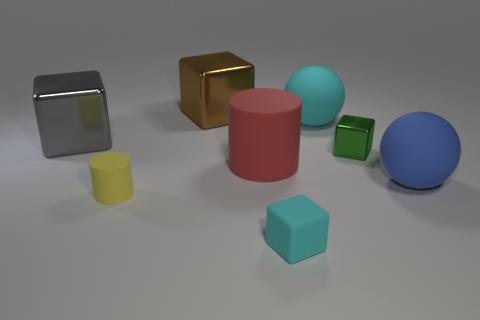There is a cyan object in front of the blue rubber ball; is its shape the same as the gray object?
Make the answer very short. Yes. What number of matte objects are on the left side of the large blue matte ball and to the right of the brown metallic cube?
Offer a terse response. 3. There is a tiny object that is behind the big blue rubber thing; what is its material?
Offer a very short reply. Metal. The green cube that is the same material as the gray cube is what size?
Provide a succinct answer. Small. Is the size of the cyan rubber thing that is behind the yellow rubber cylinder the same as the metallic block to the right of the tiny cyan rubber cube?
Your response must be concise. No. What material is the gray thing that is the same size as the red thing?
Offer a terse response. Metal. There is a block that is both in front of the big cyan sphere and to the left of the tiny cyan matte thing; what material is it?
Provide a succinct answer. Metal. Is there a tiny green cylinder?
Your answer should be compact. No. There is a rubber cube; does it have the same color as the rubber ball to the left of the tiny metallic block?
Provide a succinct answer. Yes. What is the shape of the cyan thing on the right side of the cyan thing that is on the left side of the large rubber ball that is behind the blue thing?
Offer a very short reply. Sphere. 